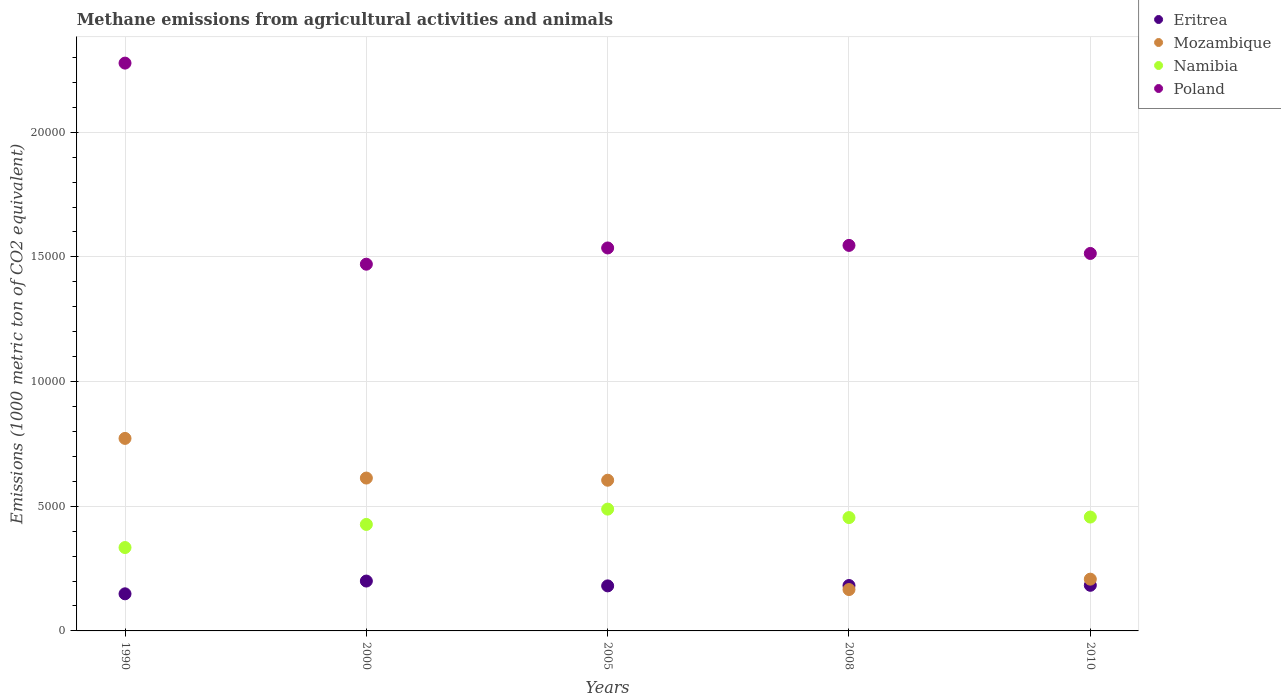How many different coloured dotlines are there?
Give a very brief answer. 4. What is the amount of methane emitted in Mozambique in 2000?
Your answer should be very brief. 6130.9. Across all years, what is the maximum amount of methane emitted in Eritrea?
Ensure brevity in your answer.  2000.3. Across all years, what is the minimum amount of methane emitted in Eritrea?
Provide a short and direct response. 1488.1. In which year was the amount of methane emitted in Eritrea maximum?
Offer a terse response. 2000. In which year was the amount of methane emitted in Poland minimum?
Give a very brief answer. 2000. What is the total amount of methane emitted in Eritrea in the graph?
Your answer should be very brief. 8945.6. What is the difference between the amount of methane emitted in Namibia in 1990 and that in 2010?
Your answer should be very brief. -1222.9. What is the difference between the amount of methane emitted in Mozambique in 2005 and the amount of methane emitted in Poland in 2000?
Offer a terse response. -8664.6. What is the average amount of methane emitted in Poland per year?
Your answer should be compact. 1.67e+04. In the year 2005, what is the difference between the amount of methane emitted in Namibia and amount of methane emitted in Poland?
Offer a very short reply. -1.05e+04. In how many years, is the amount of methane emitted in Mozambique greater than 13000 1000 metric ton?
Offer a terse response. 0. What is the ratio of the amount of methane emitted in Eritrea in 2000 to that in 2010?
Keep it short and to the point. 1.09. Is the amount of methane emitted in Poland in 2008 less than that in 2010?
Your answer should be compact. No. Is the difference between the amount of methane emitted in Namibia in 1990 and 2010 greater than the difference between the amount of methane emitted in Poland in 1990 and 2010?
Your answer should be very brief. No. What is the difference between the highest and the second highest amount of methane emitted in Mozambique?
Make the answer very short. 1590.5. What is the difference between the highest and the lowest amount of methane emitted in Mozambique?
Provide a succinct answer. 6062.1. Is it the case that in every year, the sum of the amount of methane emitted in Namibia and amount of methane emitted in Eritrea  is greater than the sum of amount of methane emitted in Mozambique and amount of methane emitted in Poland?
Offer a terse response. No. Is it the case that in every year, the sum of the amount of methane emitted in Poland and amount of methane emitted in Namibia  is greater than the amount of methane emitted in Eritrea?
Keep it short and to the point. Yes. Is the amount of methane emitted in Poland strictly greater than the amount of methane emitted in Namibia over the years?
Your answer should be compact. Yes. How many dotlines are there?
Give a very brief answer. 4. How many years are there in the graph?
Your response must be concise. 5. Are the values on the major ticks of Y-axis written in scientific E-notation?
Make the answer very short. No. Does the graph contain any zero values?
Provide a short and direct response. No. What is the title of the graph?
Offer a very short reply. Methane emissions from agricultural activities and animals. What is the label or title of the Y-axis?
Give a very brief answer. Emissions (1000 metric ton of CO2 equivalent). What is the Emissions (1000 metric ton of CO2 equivalent) of Eritrea in 1990?
Make the answer very short. 1488.1. What is the Emissions (1000 metric ton of CO2 equivalent) in Mozambique in 1990?
Provide a succinct answer. 7721.4. What is the Emissions (1000 metric ton of CO2 equivalent) in Namibia in 1990?
Make the answer very short. 3344.1. What is the Emissions (1000 metric ton of CO2 equivalent) in Poland in 1990?
Provide a short and direct response. 2.28e+04. What is the Emissions (1000 metric ton of CO2 equivalent) of Eritrea in 2000?
Offer a very short reply. 2000.3. What is the Emissions (1000 metric ton of CO2 equivalent) in Mozambique in 2000?
Offer a very short reply. 6130.9. What is the Emissions (1000 metric ton of CO2 equivalent) in Namibia in 2000?
Offer a very short reply. 4271.2. What is the Emissions (1000 metric ton of CO2 equivalent) in Poland in 2000?
Make the answer very short. 1.47e+04. What is the Emissions (1000 metric ton of CO2 equivalent) of Eritrea in 2005?
Ensure brevity in your answer.  1806.6. What is the Emissions (1000 metric ton of CO2 equivalent) in Mozambique in 2005?
Your response must be concise. 6043.9. What is the Emissions (1000 metric ton of CO2 equivalent) in Namibia in 2005?
Offer a very short reply. 4885.4. What is the Emissions (1000 metric ton of CO2 equivalent) in Poland in 2005?
Offer a terse response. 1.54e+04. What is the Emissions (1000 metric ton of CO2 equivalent) of Eritrea in 2008?
Your answer should be compact. 1820.8. What is the Emissions (1000 metric ton of CO2 equivalent) in Mozambique in 2008?
Keep it short and to the point. 1659.3. What is the Emissions (1000 metric ton of CO2 equivalent) of Namibia in 2008?
Make the answer very short. 4545.9. What is the Emissions (1000 metric ton of CO2 equivalent) of Poland in 2008?
Give a very brief answer. 1.55e+04. What is the Emissions (1000 metric ton of CO2 equivalent) in Eritrea in 2010?
Make the answer very short. 1829.8. What is the Emissions (1000 metric ton of CO2 equivalent) of Mozambique in 2010?
Offer a very short reply. 2076.1. What is the Emissions (1000 metric ton of CO2 equivalent) of Namibia in 2010?
Your answer should be compact. 4567. What is the Emissions (1000 metric ton of CO2 equivalent) in Poland in 2010?
Offer a very short reply. 1.51e+04. Across all years, what is the maximum Emissions (1000 metric ton of CO2 equivalent) of Eritrea?
Offer a terse response. 2000.3. Across all years, what is the maximum Emissions (1000 metric ton of CO2 equivalent) in Mozambique?
Offer a terse response. 7721.4. Across all years, what is the maximum Emissions (1000 metric ton of CO2 equivalent) in Namibia?
Provide a succinct answer. 4885.4. Across all years, what is the maximum Emissions (1000 metric ton of CO2 equivalent) of Poland?
Keep it short and to the point. 2.28e+04. Across all years, what is the minimum Emissions (1000 metric ton of CO2 equivalent) of Eritrea?
Your answer should be very brief. 1488.1. Across all years, what is the minimum Emissions (1000 metric ton of CO2 equivalent) of Mozambique?
Ensure brevity in your answer.  1659.3. Across all years, what is the minimum Emissions (1000 metric ton of CO2 equivalent) of Namibia?
Give a very brief answer. 3344.1. Across all years, what is the minimum Emissions (1000 metric ton of CO2 equivalent) of Poland?
Your answer should be compact. 1.47e+04. What is the total Emissions (1000 metric ton of CO2 equivalent) in Eritrea in the graph?
Your answer should be very brief. 8945.6. What is the total Emissions (1000 metric ton of CO2 equivalent) in Mozambique in the graph?
Provide a short and direct response. 2.36e+04. What is the total Emissions (1000 metric ton of CO2 equivalent) of Namibia in the graph?
Keep it short and to the point. 2.16e+04. What is the total Emissions (1000 metric ton of CO2 equivalent) of Poland in the graph?
Provide a short and direct response. 8.34e+04. What is the difference between the Emissions (1000 metric ton of CO2 equivalent) of Eritrea in 1990 and that in 2000?
Ensure brevity in your answer.  -512.2. What is the difference between the Emissions (1000 metric ton of CO2 equivalent) of Mozambique in 1990 and that in 2000?
Your answer should be very brief. 1590.5. What is the difference between the Emissions (1000 metric ton of CO2 equivalent) of Namibia in 1990 and that in 2000?
Keep it short and to the point. -927.1. What is the difference between the Emissions (1000 metric ton of CO2 equivalent) of Poland in 1990 and that in 2000?
Offer a terse response. 8065. What is the difference between the Emissions (1000 metric ton of CO2 equivalent) in Eritrea in 1990 and that in 2005?
Ensure brevity in your answer.  -318.5. What is the difference between the Emissions (1000 metric ton of CO2 equivalent) of Mozambique in 1990 and that in 2005?
Keep it short and to the point. 1677.5. What is the difference between the Emissions (1000 metric ton of CO2 equivalent) in Namibia in 1990 and that in 2005?
Give a very brief answer. -1541.3. What is the difference between the Emissions (1000 metric ton of CO2 equivalent) of Poland in 1990 and that in 2005?
Your answer should be very brief. 7413.7. What is the difference between the Emissions (1000 metric ton of CO2 equivalent) of Eritrea in 1990 and that in 2008?
Offer a terse response. -332.7. What is the difference between the Emissions (1000 metric ton of CO2 equivalent) of Mozambique in 1990 and that in 2008?
Provide a succinct answer. 6062.1. What is the difference between the Emissions (1000 metric ton of CO2 equivalent) in Namibia in 1990 and that in 2008?
Ensure brevity in your answer.  -1201.8. What is the difference between the Emissions (1000 metric ton of CO2 equivalent) in Poland in 1990 and that in 2008?
Make the answer very short. 7311.1. What is the difference between the Emissions (1000 metric ton of CO2 equivalent) of Eritrea in 1990 and that in 2010?
Your response must be concise. -341.7. What is the difference between the Emissions (1000 metric ton of CO2 equivalent) of Mozambique in 1990 and that in 2010?
Provide a short and direct response. 5645.3. What is the difference between the Emissions (1000 metric ton of CO2 equivalent) in Namibia in 1990 and that in 2010?
Your response must be concise. -1222.9. What is the difference between the Emissions (1000 metric ton of CO2 equivalent) in Poland in 1990 and that in 2010?
Your response must be concise. 7634.1. What is the difference between the Emissions (1000 metric ton of CO2 equivalent) of Eritrea in 2000 and that in 2005?
Keep it short and to the point. 193.7. What is the difference between the Emissions (1000 metric ton of CO2 equivalent) in Namibia in 2000 and that in 2005?
Provide a succinct answer. -614.2. What is the difference between the Emissions (1000 metric ton of CO2 equivalent) in Poland in 2000 and that in 2005?
Offer a terse response. -651.3. What is the difference between the Emissions (1000 metric ton of CO2 equivalent) in Eritrea in 2000 and that in 2008?
Give a very brief answer. 179.5. What is the difference between the Emissions (1000 metric ton of CO2 equivalent) of Mozambique in 2000 and that in 2008?
Your response must be concise. 4471.6. What is the difference between the Emissions (1000 metric ton of CO2 equivalent) of Namibia in 2000 and that in 2008?
Make the answer very short. -274.7. What is the difference between the Emissions (1000 metric ton of CO2 equivalent) of Poland in 2000 and that in 2008?
Ensure brevity in your answer.  -753.9. What is the difference between the Emissions (1000 metric ton of CO2 equivalent) in Eritrea in 2000 and that in 2010?
Keep it short and to the point. 170.5. What is the difference between the Emissions (1000 metric ton of CO2 equivalent) of Mozambique in 2000 and that in 2010?
Your response must be concise. 4054.8. What is the difference between the Emissions (1000 metric ton of CO2 equivalent) of Namibia in 2000 and that in 2010?
Your answer should be very brief. -295.8. What is the difference between the Emissions (1000 metric ton of CO2 equivalent) in Poland in 2000 and that in 2010?
Offer a very short reply. -430.9. What is the difference between the Emissions (1000 metric ton of CO2 equivalent) of Eritrea in 2005 and that in 2008?
Your response must be concise. -14.2. What is the difference between the Emissions (1000 metric ton of CO2 equivalent) of Mozambique in 2005 and that in 2008?
Offer a very short reply. 4384.6. What is the difference between the Emissions (1000 metric ton of CO2 equivalent) in Namibia in 2005 and that in 2008?
Offer a very short reply. 339.5. What is the difference between the Emissions (1000 metric ton of CO2 equivalent) in Poland in 2005 and that in 2008?
Offer a very short reply. -102.6. What is the difference between the Emissions (1000 metric ton of CO2 equivalent) in Eritrea in 2005 and that in 2010?
Make the answer very short. -23.2. What is the difference between the Emissions (1000 metric ton of CO2 equivalent) in Mozambique in 2005 and that in 2010?
Give a very brief answer. 3967.8. What is the difference between the Emissions (1000 metric ton of CO2 equivalent) of Namibia in 2005 and that in 2010?
Your answer should be compact. 318.4. What is the difference between the Emissions (1000 metric ton of CO2 equivalent) in Poland in 2005 and that in 2010?
Offer a terse response. 220.4. What is the difference between the Emissions (1000 metric ton of CO2 equivalent) in Mozambique in 2008 and that in 2010?
Provide a short and direct response. -416.8. What is the difference between the Emissions (1000 metric ton of CO2 equivalent) of Namibia in 2008 and that in 2010?
Your answer should be compact. -21.1. What is the difference between the Emissions (1000 metric ton of CO2 equivalent) in Poland in 2008 and that in 2010?
Your response must be concise. 323. What is the difference between the Emissions (1000 metric ton of CO2 equivalent) of Eritrea in 1990 and the Emissions (1000 metric ton of CO2 equivalent) of Mozambique in 2000?
Give a very brief answer. -4642.8. What is the difference between the Emissions (1000 metric ton of CO2 equivalent) of Eritrea in 1990 and the Emissions (1000 metric ton of CO2 equivalent) of Namibia in 2000?
Give a very brief answer. -2783.1. What is the difference between the Emissions (1000 metric ton of CO2 equivalent) in Eritrea in 1990 and the Emissions (1000 metric ton of CO2 equivalent) in Poland in 2000?
Keep it short and to the point. -1.32e+04. What is the difference between the Emissions (1000 metric ton of CO2 equivalent) in Mozambique in 1990 and the Emissions (1000 metric ton of CO2 equivalent) in Namibia in 2000?
Provide a short and direct response. 3450.2. What is the difference between the Emissions (1000 metric ton of CO2 equivalent) of Mozambique in 1990 and the Emissions (1000 metric ton of CO2 equivalent) of Poland in 2000?
Your answer should be compact. -6987.1. What is the difference between the Emissions (1000 metric ton of CO2 equivalent) of Namibia in 1990 and the Emissions (1000 metric ton of CO2 equivalent) of Poland in 2000?
Provide a succinct answer. -1.14e+04. What is the difference between the Emissions (1000 metric ton of CO2 equivalent) of Eritrea in 1990 and the Emissions (1000 metric ton of CO2 equivalent) of Mozambique in 2005?
Provide a succinct answer. -4555.8. What is the difference between the Emissions (1000 metric ton of CO2 equivalent) in Eritrea in 1990 and the Emissions (1000 metric ton of CO2 equivalent) in Namibia in 2005?
Ensure brevity in your answer.  -3397.3. What is the difference between the Emissions (1000 metric ton of CO2 equivalent) of Eritrea in 1990 and the Emissions (1000 metric ton of CO2 equivalent) of Poland in 2005?
Offer a terse response. -1.39e+04. What is the difference between the Emissions (1000 metric ton of CO2 equivalent) of Mozambique in 1990 and the Emissions (1000 metric ton of CO2 equivalent) of Namibia in 2005?
Provide a short and direct response. 2836. What is the difference between the Emissions (1000 metric ton of CO2 equivalent) in Mozambique in 1990 and the Emissions (1000 metric ton of CO2 equivalent) in Poland in 2005?
Keep it short and to the point. -7638.4. What is the difference between the Emissions (1000 metric ton of CO2 equivalent) in Namibia in 1990 and the Emissions (1000 metric ton of CO2 equivalent) in Poland in 2005?
Make the answer very short. -1.20e+04. What is the difference between the Emissions (1000 metric ton of CO2 equivalent) in Eritrea in 1990 and the Emissions (1000 metric ton of CO2 equivalent) in Mozambique in 2008?
Give a very brief answer. -171.2. What is the difference between the Emissions (1000 metric ton of CO2 equivalent) of Eritrea in 1990 and the Emissions (1000 metric ton of CO2 equivalent) of Namibia in 2008?
Offer a very short reply. -3057.8. What is the difference between the Emissions (1000 metric ton of CO2 equivalent) of Eritrea in 1990 and the Emissions (1000 metric ton of CO2 equivalent) of Poland in 2008?
Offer a very short reply. -1.40e+04. What is the difference between the Emissions (1000 metric ton of CO2 equivalent) in Mozambique in 1990 and the Emissions (1000 metric ton of CO2 equivalent) in Namibia in 2008?
Provide a short and direct response. 3175.5. What is the difference between the Emissions (1000 metric ton of CO2 equivalent) in Mozambique in 1990 and the Emissions (1000 metric ton of CO2 equivalent) in Poland in 2008?
Offer a very short reply. -7741. What is the difference between the Emissions (1000 metric ton of CO2 equivalent) of Namibia in 1990 and the Emissions (1000 metric ton of CO2 equivalent) of Poland in 2008?
Your answer should be very brief. -1.21e+04. What is the difference between the Emissions (1000 metric ton of CO2 equivalent) of Eritrea in 1990 and the Emissions (1000 metric ton of CO2 equivalent) of Mozambique in 2010?
Ensure brevity in your answer.  -588. What is the difference between the Emissions (1000 metric ton of CO2 equivalent) of Eritrea in 1990 and the Emissions (1000 metric ton of CO2 equivalent) of Namibia in 2010?
Provide a short and direct response. -3078.9. What is the difference between the Emissions (1000 metric ton of CO2 equivalent) of Eritrea in 1990 and the Emissions (1000 metric ton of CO2 equivalent) of Poland in 2010?
Your response must be concise. -1.37e+04. What is the difference between the Emissions (1000 metric ton of CO2 equivalent) of Mozambique in 1990 and the Emissions (1000 metric ton of CO2 equivalent) of Namibia in 2010?
Ensure brevity in your answer.  3154.4. What is the difference between the Emissions (1000 metric ton of CO2 equivalent) in Mozambique in 1990 and the Emissions (1000 metric ton of CO2 equivalent) in Poland in 2010?
Provide a succinct answer. -7418. What is the difference between the Emissions (1000 metric ton of CO2 equivalent) in Namibia in 1990 and the Emissions (1000 metric ton of CO2 equivalent) in Poland in 2010?
Give a very brief answer. -1.18e+04. What is the difference between the Emissions (1000 metric ton of CO2 equivalent) in Eritrea in 2000 and the Emissions (1000 metric ton of CO2 equivalent) in Mozambique in 2005?
Offer a very short reply. -4043.6. What is the difference between the Emissions (1000 metric ton of CO2 equivalent) in Eritrea in 2000 and the Emissions (1000 metric ton of CO2 equivalent) in Namibia in 2005?
Offer a terse response. -2885.1. What is the difference between the Emissions (1000 metric ton of CO2 equivalent) of Eritrea in 2000 and the Emissions (1000 metric ton of CO2 equivalent) of Poland in 2005?
Offer a terse response. -1.34e+04. What is the difference between the Emissions (1000 metric ton of CO2 equivalent) in Mozambique in 2000 and the Emissions (1000 metric ton of CO2 equivalent) in Namibia in 2005?
Provide a short and direct response. 1245.5. What is the difference between the Emissions (1000 metric ton of CO2 equivalent) in Mozambique in 2000 and the Emissions (1000 metric ton of CO2 equivalent) in Poland in 2005?
Your answer should be compact. -9228.9. What is the difference between the Emissions (1000 metric ton of CO2 equivalent) of Namibia in 2000 and the Emissions (1000 metric ton of CO2 equivalent) of Poland in 2005?
Keep it short and to the point. -1.11e+04. What is the difference between the Emissions (1000 metric ton of CO2 equivalent) in Eritrea in 2000 and the Emissions (1000 metric ton of CO2 equivalent) in Mozambique in 2008?
Your answer should be compact. 341. What is the difference between the Emissions (1000 metric ton of CO2 equivalent) of Eritrea in 2000 and the Emissions (1000 metric ton of CO2 equivalent) of Namibia in 2008?
Your answer should be very brief. -2545.6. What is the difference between the Emissions (1000 metric ton of CO2 equivalent) in Eritrea in 2000 and the Emissions (1000 metric ton of CO2 equivalent) in Poland in 2008?
Provide a succinct answer. -1.35e+04. What is the difference between the Emissions (1000 metric ton of CO2 equivalent) of Mozambique in 2000 and the Emissions (1000 metric ton of CO2 equivalent) of Namibia in 2008?
Ensure brevity in your answer.  1585. What is the difference between the Emissions (1000 metric ton of CO2 equivalent) in Mozambique in 2000 and the Emissions (1000 metric ton of CO2 equivalent) in Poland in 2008?
Offer a very short reply. -9331.5. What is the difference between the Emissions (1000 metric ton of CO2 equivalent) of Namibia in 2000 and the Emissions (1000 metric ton of CO2 equivalent) of Poland in 2008?
Ensure brevity in your answer.  -1.12e+04. What is the difference between the Emissions (1000 metric ton of CO2 equivalent) of Eritrea in 2000 and the Emissions (1000 metric ton of CO2 equivalent) of Mozambique in 2010?
Keep it short and to the point. -75.8. What is the difference between the Emissions (1000 metric ton of CO2 equivalent) of Eritrea in 2000 and the Emissions (1000 metric ton of CO2 equivalent) of Namibia in 2010?
Provide a short and direct response. -2566.7. What is the difference between the Emissions (1000 metric ton of CO2 equivalent) in Eritrea in 2000 and the Emissions (1000 metric ton of CO2 equivalent) in Poland in 2010?
Offer a very short reply. -1.31e+04. What is the difference between the Emissions (1000 metric ton of CO2 equivalent) of Mozambique in 2000 and the Emissions (1000 metric ton of CO2 equivalent) of Namibia in 2010?
Give a very brief answer. 1563.9. What is the difference between the Emissions (1000 metric ton of CO2 equivalent) in Mozambique in 2000 and the Emissions (1000 metric ton of CO2 equivalent) in Poland in 2010?
Offer a very short reply. -9008.5. What is the difference between the Emissions (1000 metric ton of CO2 equivalent) in Namibia in 2000 and the Emissions (1000 metric ton of CO2 equivalent) in Poland in 2010?
Make the answer very short. -1.09e+04. What is the difference between the Emissions (1000 metric ton of CO2 equivalent) of Eritrea in 2005 and the Emissions (1000 metric ton of CO2 equivalent) of Mozambique in 2008?
Offer a very short reply. 147.3. What is the difference between the Emissions (1000 metric ton of CO2 equivalent) of Eritrea in 2005 and the Emissions (1000 metric ton of CO2 equivalent) of Namibia in 2008?
Give a very brief answer. -2739.3. What is the difference between the Emissions (1000 metric ton of CO2 equivalent) in Eritrea in 2005 and the Emissions (1000 metric ton of CO2 equivalent) in Poland in 2008?
Your answer should be compact. -1.37e+04. What is the difference between the Emissions (1000 metric ton of CO2 equivalent) in Mozambique in 2005 and the Emissions (1000 metric ton of CO2 equivalent) in Namibia in 2008?
Ensure brevity in your answer.  1498. What is the difference between the Emissions (1000 metric ton of CO2 equivalent) of Mozambique in 2005 and the Emissions (1000 metric ton of CO2 equivalent) of Poland in 2008?
Give a very brief answer. -9418.5. What is the difference between the Emissions (1000 metric ton of CO2 equivalent) of Namibia in 2005 and the Emissions (1000 metric ton of CO2 equivalent) of Poland in 2008?
Offer a terse response. -1.06e+04. What is the difference between the Emissions (1000 metric ton of CO2 equivalent) of Eritrea in 2005 and the Emissions (1000 metric ton of CO2 equivalent) of Mozambique in 2010?
Make the answer very short. -269.5. What is the difference between the Emissions (1000 metric ton of CO2 equivalent) in Eritrea in 2005 and the Emissions (1000 metric ton of CO2 equivalent) in Namibia in 2010?
Your answer should be very brief. -2760.4. What is the difference between the Emissions (1000 metric ton of CO2 equivalent) of Eritrea in 2005 and the Emissions (1000 metric ton of CO2 equivalent) of Poland in 2010?
Provide a short and direct response. -1.33e+04. What is the difference between the Emissions (1000 metric ton of CO2 equivalent) in Mozambique in 2005 and the Emissions (1000 metric ton of CO2 equivalent) in Namibia in 2010?
Provide a short and direct response. 1476.9. What is the difference between the Emissions (1000 metric ton of CO2 equivalent) of Mozambique in 2005 and the Emissions (1000 metric ton of CO2 equivalent) of Poland in 2010?
Offer a terse response. -9095.5. What is the difference between the Emissions (1000 metric ton of CO2 equivalent) in Namibia in 2005 and the Emissions (1000 metric ton of CO2 equivalent) in Poland in 2010?
Keep it short and to the point. -1.03e+04. What is the difference between the Emissions (1000 metric ton of CO2 equivalent) of Eritrea in 2008 and the Emissions (1000 metric ton of CO2 equivalent) of Mozambique in 2010?
Your answer should be very brief. -255.3. What is the difference between the Emissions (1000 metric ton of CO2 equivalent) of Eritrea in 2008 and the Emissions (1000 metric ton of CO2 equivalent) of Namibia in 2010?
Your answer should be compact. -2746.2. What is the difference between the Emissions (1000 metric ton of CO2 equivalent) in Eritrea in 2008 and the Emissions (1000 metric ton of CO2 equivalent) in Poland in 2010?
Your answer should be compact. -1.33e+04. What is the difference between the Emissions (1000 metric ton of CO2 equivalent) in Mozambique in 2008 and the Emissions (1000 metric ton of CO2 equivalent) in Namibia in 2010?
Your response must be concise. -2907.7. What is the difference between the Emissions (1000 metric ton of CO2 equivalent) of Mozambique in 2008 and the Emissions (1000 metric ton of CO2 equivalent) of Poland in 2010?
Provide a short and direct response. -1.35e+04. What is the difference between the Emissions (1000 metric ton of CO2 equivalent) of Namibia in 2008 and the Emissions (1000 metric ton of CO2 equivalent) of Poland in 2010?
Provide a succinct answer. -1.06e+04. What is the average Emissions (1000 metric ton of CO2 equivalent) in Eritrea per year?
Give a very brief answer. 1789.12. What is the average Emissions (1000 metric ton of CO2 equivalent) of Mozambique per year?
Provide a short and direct response. 4726.32. What is the average Emissions (1000 metric ton of CO2 equivalent) of Namibia per year?
Make the answer very short. 4322.72. What is the average Emissions (1000 metric ton of CO2 equivalent) of Poland per year?
Your response must be concise. 1.67e+04. In the year 1990, what is the difference between the Emissions (1000 metric ton of CO2 equivalent) of Eritrea and Emissions (1000 metric ton of CO2 equivalent) of Mozambique?
Provide a short and direct response. -6233.3. In the year 1990, what is the difference between the Emissions (1000 metric ton of CO2 equivalent) of Eritrea and Emissions (1000 metric ton of CO2 equivalent) of Namibia?
Offer a very short reply. -1856. In the year 1990, what is the difference between the Emissions (1000 metric ton of CO2 equivalent) in Eritrea and Emissions (1000 metric ton of CO2 equivalent) in Poland?
Your answer should be very brief. -2.13e+04. In the year 1990, what is the difference between the Emissions (1000 metric ton of CO2 equivalent) in Mozambique and Emissions (1000 metric ton of CO2 equivalent) in Namibia?
Your answer should be very brief. 4377.3. In the year 1990, what is the difference between the Emissions (1000 metric ton of CO2 equivalent) in Mozambique and Emissions (1000 metric ton of CO2 equivalent) in Poland?
Provide a succinct answer. -1.51e+04. In the year 1990, what is the difference between the Emissions (1000 metric ton of CO2 equivalent) of Namibia and Emissions (1000 metric ton of CO2 equivalent) of Poland?
Make the answer very short. -1.94e+04. In the year 2000, what is the difference between the Emissions (1000 metric ton of CO2 equivalent) in Eritrea and Emissions (1000 metric ton of CO2 equivalent) in Mozambique?
Keep it short and to the point. -4130.6. In the year 2000, what is the difference between the Emissions (1000 metric ton of CO2 equivalent) of Eritrea and Emissions (1000 metric ton of CO2 equivalent) of Namibia?
Keep it short and to the point. -2270.9. In the year 2000, what is the difference between the Emissions (1000 metric ton of CO2 equivalent) in Eritrea and Emissions (1000 metric ton of CO2 equivalent) in Poland?
Your answer should be very brief. -1.27e+04. In the year 2000, what is the difference between the Emissions (1000 metric ton of CO2 equivalent) of Mozambique and Emissions (1000 metric ton of CO2 equivalent) of Namibia?
Your answer should be very brief. 1859.7. In the year 2000, what is the difference between the Emissions (1000 metric ton of CO2 equivalent) of Mozambique and Emissions (1000 metric ton of CO2 equivalent) of Poland?
Offer a very short reply. -8577.6. In the year 2000, what is the difference between the Emissions (1000 metric ton of CO2 equivalent) in Namibia and Emissions (1000 metric ton of CO2 equivalent) in Poland?
Your response must be concise. -1.04e+04. In the year 2005, what is the difference between the Emissions (1000 metric ton of CO2 equivalent) of Eritrea and Emissions (1000 metric ton of CO2 equivalent) of Mozambique?
Your answer should be very brief. -4237.3. In the year 2005, what is the difference between the Emissions (1000 metric ton of CO2 equivalent) of Eritrea and Emissions (1000 metric ton of CO2 equivalent) of Namibia?
Offer a terse response. -3078.8. In the year 2005, what is the difference between the Emissions (1000 metric ton of CO2 equivalent) in Eritrea and Emissions (1000 metric ton of CO2 equivalent) in Poland?
Provide a succinct answer. -1.36e+04. In the year 2005, what is the difference between the Emissions (1000 metric ton of CO2 equivalent) of Mozambique and Emissions (1000 metric ton of CO2 equivalent) of Namibia?
Your answer should be compact. 1158.5. In the year 2005, what is the difference between the Emissions (1000 metric ton of CO2 equivalent) in Mozambique and Emissions (1000 metric ton of CO2 equivalent) in Poland?
Offer a very short reply. -9315.9. In the year 2005, what is the difference between the Emissions (1000 metric ton of CO2 equivalent) of Namibia and Emissions (1000 metric ton of CO2 equivalent) of Poland?
Your response must be concise. -1.05e+04. In the year 2008, what is the difference between the Emissions (1000 metric ton of CO2 equivalent) of Eritrea and Emissions (1000 metric ton of CO2 equivalent) of Mozambique?
Your answer should be compact. 161.5. In the year 2008, what is the difference between the Emissions (1000 metric ton of CO2 equivalent) of Eritrea and Emissions (1000 metric ton of CO2 equivalent) of Namibia?
Keep it short and to the point. -2725.1. In the year 2008, what is the difference between the Emissions (1000 metric ton of CO2 equivalent) of Eritrea and Emissions (1000 metric ton of CO2 equivalent) of Poland?
Provide a succinct answer. -1.36e+04. In the year 2008, what is the difference between the Emissions (1000 metric ton of CO2 equivalent) of Mozambique and Emissions (1000 metric ton of CO2 equivalent) of Namibia?
Your answer should be very brief. -2886.6. In the year 2008, what is the difference between the Emissions (1000 metric ton of CO2 equivalent) in Mozambique and Emissions (1000 metric ton of CO2 equivalent) in Poland?
Keep it short and to the point. -1.38e+04. In the year 2008, what is the difference between the Emissions (1000 metric ton of CO2 equivalent) of Namibia and Emissions (1000 metric ton of CO2 equivalent) of Poland?
Offer a very short reply. -1.09e+04. In the year 2010, what is the difference between the Emissions (1000 metric ton of CO2 equivalent) in Eritrea and Emissions (1000 metric ton of CO2 equivalent) in Mozambique?
Offer a very short reply. -246.3. In the year 2010, what is the difference between the Emissions (1000 metric ton of CO2 equivalent) in Eritrea and Emissions (1000 metric ton of CO2 equivalent) in Namibia?
Your answer should be compact. -2737.2. In the year 2010, what is the difference between the Emissions (1000 metric ton of CO2 equivalent) of Eritrea and Emissions (1000 metric ton of CO2 equivalent) of Poland?
Offer a terse response. -1.33e+04. In the year 2010, what is the difference between the Emissions (1000 metric ton of CO2 equivalent) in Mozambique and Emissions (1000 metric ton of CO2 equivalent) in Namibia?
Offer a very short reply. -2490.9. In the year 2010, what is the difference between the Emissions (1000 metric ton of CO2 equivalent) in Mozambique and Emissions (1000 metric ton of CO2 equivalent) in Poland?
Give a very brief answer. -1.31e+04. In the year 2010, what is the difference between the Emissions (1000 metric ton of CO2 equivalent) in Namibia and Emissions (1000 metric ton of CO2 equivalent) in Poland?
Make the answer very short. -1.06e+04. What is the ratio of the Emissions (1000 metric ton of CO2 equivalent) of Eritrea in 1990 to that in 2000?
Offer a terse response. 0.74. What is the ratio of the Emissions (1000 metric ton of CO2 equivalent) of Mozambique in 1990 to that in 2000?
Give a very brief answer. 1.26. What is the ratio of the Emissions (1000 metric ton of CO2 equivalent) in Namibia in 1990 to that in 2000?
Your answer should be compact. 0.78. What is the ratio of the Emissions (1000 metric ton of CO2 equivalent) of Poland in 1990 to that in 2000?
Give a very brief answer. 1.55. What is the ratio of the Emissions (1000 metric ton of CO2 equivalent) in Eritrea in 1990 to that in 2005?
Your answer should be very brief. 0.82. What is the ratio of the Emissions (1000 metric ton of CO2 equivalent) of Mozambique in 1990 to that in 2005?
Make the answer very short. 1.28. What is the ratio of the Emissions (1000 metric ton of CO2 equivalent) in Namibia in 1990 to that in 2005?
Provide a short and direct response. 0.68. What is the ratio of the Emissions (1000 metric ton of CO2 equivalent) of Poland in 1990 to that in 2005?
Offer a very short reply. 1.48. What is the ratio of the Emissions (1000 metric ton of CO2 equivalent) in Eritrea in 1990 to that in 2008?
Provide a short and direct response. 0.82. What is the ratio of the Emissions (1000 metric ton of CO2 equivalent) of Mozambique in 1990 to that in 2008?
Keep it short and to the point. 4.65. What is the ratio of the Emissions (1000 metric ton of CO2 equivalent) in Namibia in 1990 to that in 2008?
Give a very brief answer. 0.74. What is the ratio of the Emissions (1000 metric ton of CO2 equivalent) of Poland in 1990 to that in 2008?
Offer a terse response. 1.47. What is the ratio of the Emissions (1000 metric ton of CO2 equivalent) in Eritrea in 1990 to that in 2010?
Keep it short and to the point. 0.81. What is the ratio of the Emissions (1000 metric ton of CO2 equivalent) of Mozambique in 1990 to that in 2010?
Give a very brief answer. 3.72. What is the ratio of the Emissions (1000 metric ton of CO2 equivalent) of Namibia in 1990 to that in 2010?
Offer a very short reply. 0.73. What is the ratio of the Emissions (1000 metric ton of CO2 equivalent) of Poland in 1990 to that in 2010?
Keep it short and to the point. 1.5. What is the ratio of the Emissions (1000 metric ton of CO2 equivalent) of Eritrea in 2000 to that in 2005?
Your response must be concise. 1.11. What is the ratio of the Emissions (1000 metric ton of CO2 equivalent) of Mozambique in 2000 to that in 2005?
Provide a succinct answer. 1.01. What is the ratio of the Emissions (1000 metric ton of CO2 equivalent) in Namibia in 2000 to that in 2005?
Offer a terse response. 0.87. What is the ratio of the Emissions (1000 metric ton of CO2 equivalent) of Poland in 2000 to that in 2005?
Provide a short and direct response. 0.96. What is the ratio of the Emissions (1000 metric ton of CO2 equivalent) in Eritrea in 2000 to that in 2008?
Your answer should be very brief. 1.1. What is the ratio of the Emissions (1000 metric ton of CO2 equivalent) in Mozambique in 2000 to that in 2008?
Your answer should be compact. 3.69. What is the ratio of the Emissions (1000 metric ton of CO2 equivalent) of Namibia in 2000 to that in 2008?
Ensure brevity in your answer.  0.94. What is the ratio of the Emissions (1000 metric ton of CO2 equivalent) in Poland in 2000 to that in 2008?
Offer a terse response. 0.95. What is the ratio of the Emissions (1000 metric ton of CO2 equivalent) in Eritrea in 2000 to that in 2010?
Make the answer very short. 1.09. What is the ratio of the Emissions (1000 metric ton of CO2 equivalent) of Mozambique in 2000 to that in 2010?
Your response must be concise. 2.95. What is the ratio of the Emissions (1000 metric ton of CO2 equivalent) in Namibia in 2000 to that in 2010?
Provide a short and direct response. 0.94. What is the ratio of the Emissions (1000 metric ton of CO2 equivalent) in Poland in 2000 to that in 2010?
Offer a terse response. 0.97. What is the ratio of the Emissions (1000 metric ton of CO2 equivalent) in Eritrea in 2005 to that in 2008?
Offer a terse response. 0.99. What is the ratio of the Emissions (1000 metric ton of CO2 equivalent) in Mozambique in 2005 to that in 2008?
Your response must be concise. 3.64. What is the ratio of the Emissions (1000 metric ton of CO2 equivalent) in Namibia in 2005 to that in 2008?
Keep it short and to the point. 1.07. What is the ratio of the Emissions (1000 metric ton of CO2 equivalent) in Eritrea in 2005 to that in 2010?
Your answer should be compact. 0.99. What is the ratio of the Emissions (1000 metric ton of CO2 equivalent) in Mozambique in 2005 to that in 2010?
Give a very brief answer. 2.91. What is the ratio of the Emissions (1000 metric ton of CO2 equivalent) of Namibia in 2005 to that in 2010?
Give a very brief answer. 1.07. What is the ratio of the Emissions (1000 metric ton of CO2 equivalent) of Poland in 2005 to that in 2010?
Provide a short and direct response. 1.01. What is the ratio of the Emissions (1000 metric ton of CO2 equivalent) of Mozambique in 2008 to that in 2010?
Your answer should be compact. 0.8. What is the ratio of the Emissions (1000 metric ton of CO2 equivalent) in Poland in 2008 to that in 2010?
Make the answer very short. 1.02. What is the difference between the highest and the second highest Emissions (1000 metric ton of CO2 equivalent) in Eritrea?
Ensure brevity in your answer.  170.5. What is the difference between the highest and the second highest Emissions (1000 metric ton of CO2 equivalent) of Mozambique?
Keep it short and to the point. 1590.5. What is the difference between the highest and the second highest Emissions (1000 metric ton of CO2 equivalent) in Namibia?
Make the answer very short. 318.4. What is the difference between the highest and the second highest Emissions (1000 metric ton of CO2 equivalent) of Poland?
Your answer should be very brief. 7311.1. What is the difference between the highest and the lowest Emissions (1000 metric ton of CO2 equivalent) of Eritrea?
Your response must be concise. 512.2. What is the difference between the highest and the lowest Emissions (1000 metric ton of CO2 equivalent) of Mozambique?
Your answer should be very brief. 6062.1. What is the difference between the highest and the lowest Emissions (1000 metric ton of CO2 equivalent) in Namibia?
Your response must be concise. 1541.3. What is the difference between the highest and the lowest Emissions (1000 metric ton of CO2 equivalent) of Poland?
Offer a very short reply. 8065. 